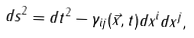Convert formula to latex. <formula><loc_0><loc_0><loc_500><loc_500>d s ^ { 2 } = d t ^ { 2 } - \gamma _ { i j } ( \vec { x } , t ) d x ^ { i } d x ^ { j } ,</formula> 